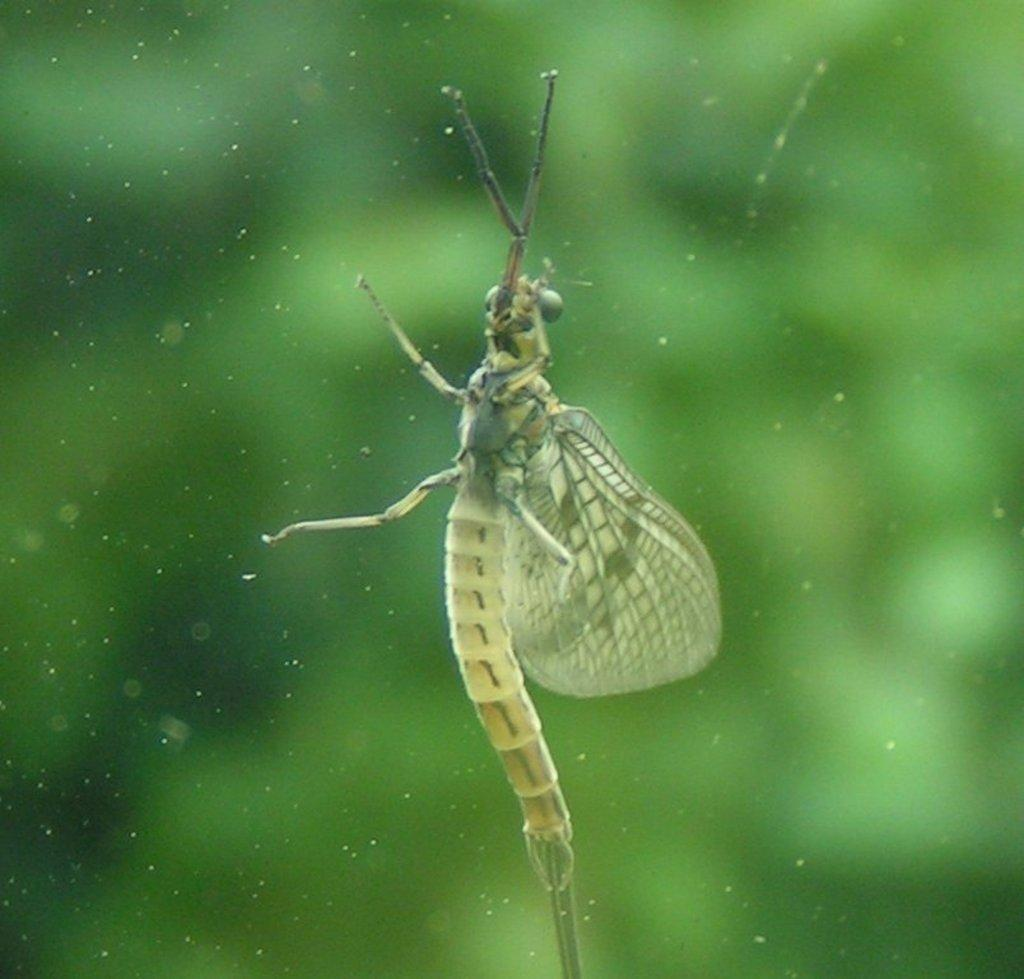What type of insect is in the picture? There is a net-winged insect in the picture. What are the two distinct features of the insect? The insect has two antennas and four legs. How would you describe the background of the image? The background of the image is green and blurred. What type of rail can be seen in the image? There is no rail present in the image; it features a net-winged insect with a green and blurred background. What color is the tin in the image? There is no tin present in the image; it features a net-winged insect with a green and blurred background. 